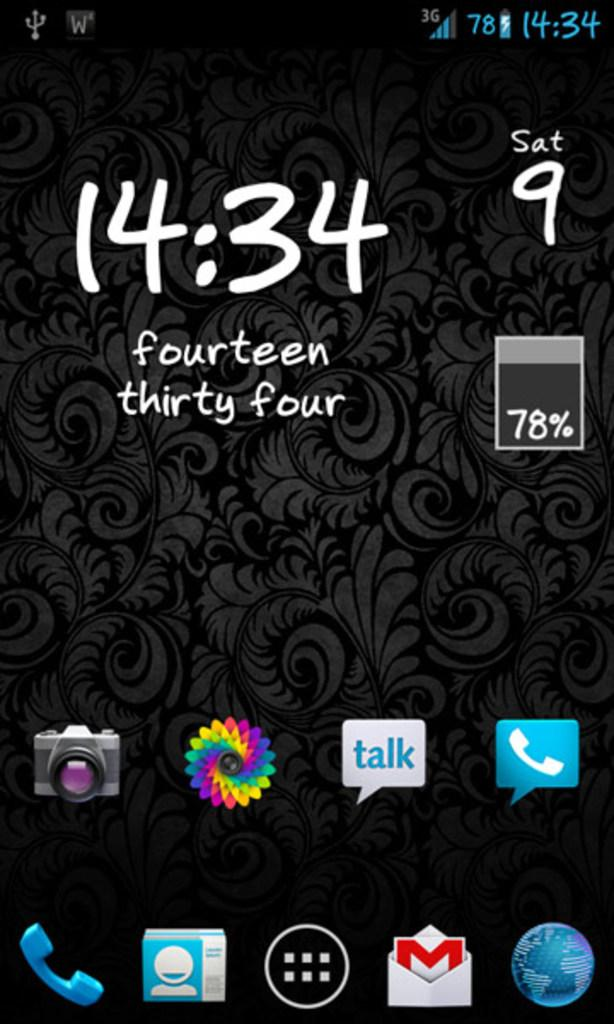Provide a one-sentence caption for the provided image. A phone screen shows the battery charge level at 78%. 